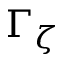<formula> <loc_0><loc_0><loc_500><loc_500>\Gamma _ { \zeta }</formula> 